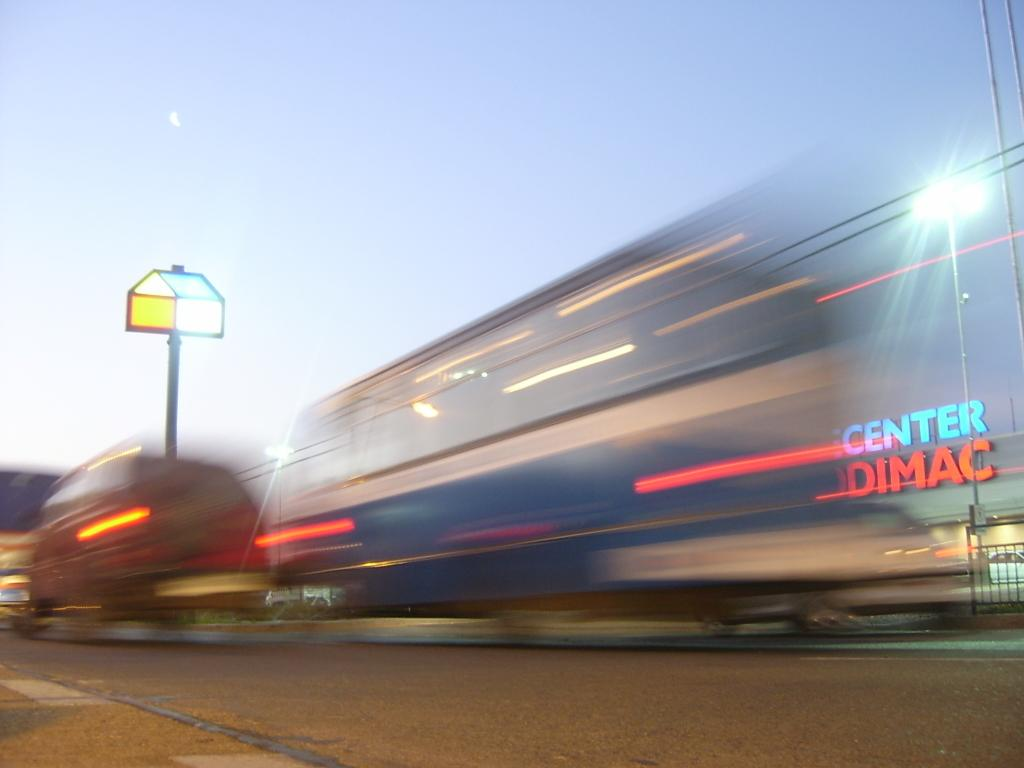What is the main feature of the image? There is a road in the image. What else can be seen on the road? There is a vehicle in the image. What is visible above the road and vehicle? The sky is visible at the top of the image. Can you tell me how many pairs of scissors are on the road in the image? There are no scissors present in the image; it only features a road and a vehicle. 